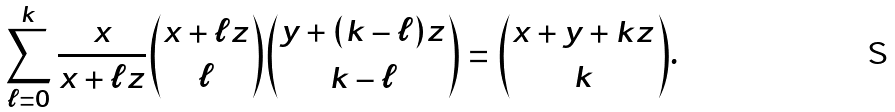<formula> <loc_0><loc_0><loc_500><loc_500>\sum _ { \ell = 0 } ^ { k } \frac { x } { x + \ell z } \binom { x + \ell z } { \ell } \binom { y + ( k - \ell ) z } { k - \ell } = \binom { x + y + k z } { k } .</formula> 